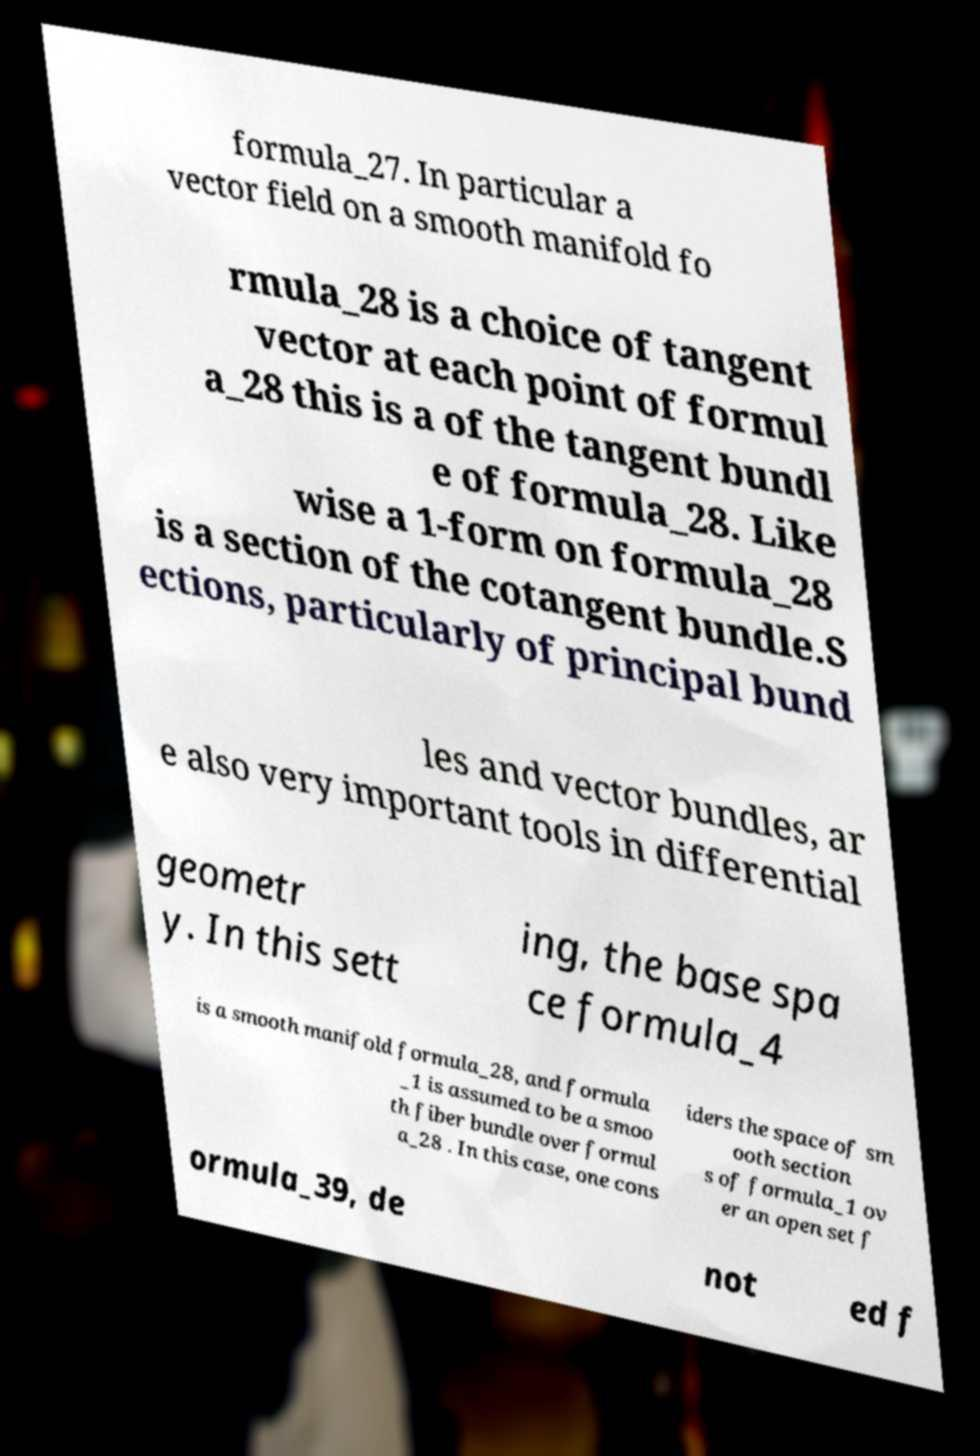Please identify and transcribe the text found in this image. formula_27. In particular a vector field on a smooth manifold fo rmula_28 is a choice of tangent vector at each point of formul a_28 this is a of the tangent bundl e of formula_28. Like wise a 1-form on formula_28 is a section of the cotangent bundle.S ections, particularly of principal bund les and vector bundles, ar e also very important tools in differential geometr y. In this sett ing, the base spa ce formula_4 is a smooth manifold formula_28, and formula _1 is assumed to be a smoo th fiber bundle over formul a_28 . In this case, one cons iders the space of sm ooth section s of formula_1 ov er an open set f ormula_39, de not ed f 